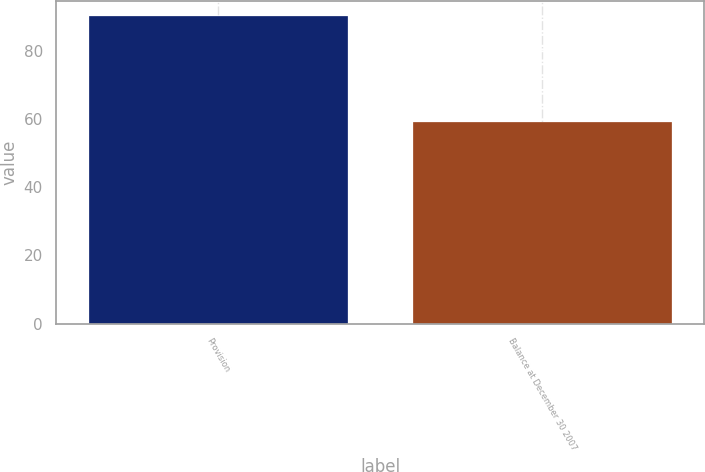Convert chart to OTSL. <chart><loc_0><loc_0><loc_500><loc_500><bar_chart><fcel>Provision<fcel>Balance at December 30 2007<nl><fcel>90<fcel>59<nl></chart> 